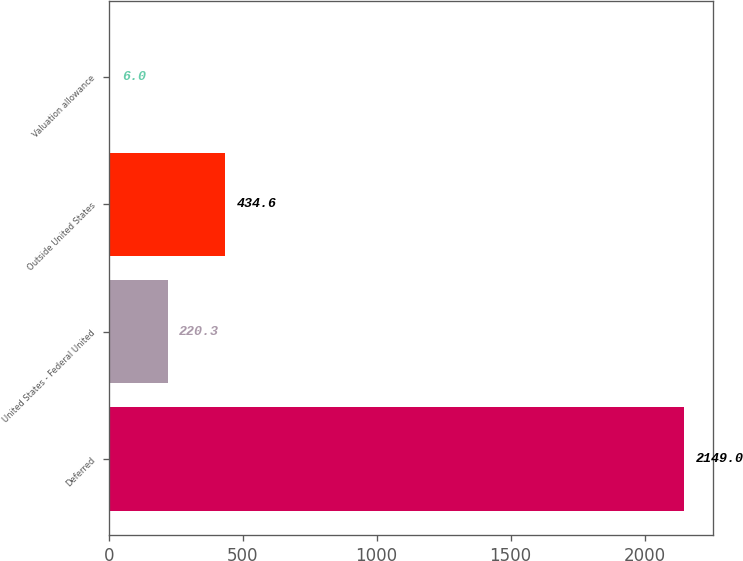<chart> <loc_0><loc_0><loc_500><loc_500><bar_chart><fcel>Deferred<fcel>United States - Federal United<fcel>Outside United States<fcel>Valuation allowance<nl><fcel>2149<fcel>220.3<fcel>434.6<fcel>6<nl></chart> 